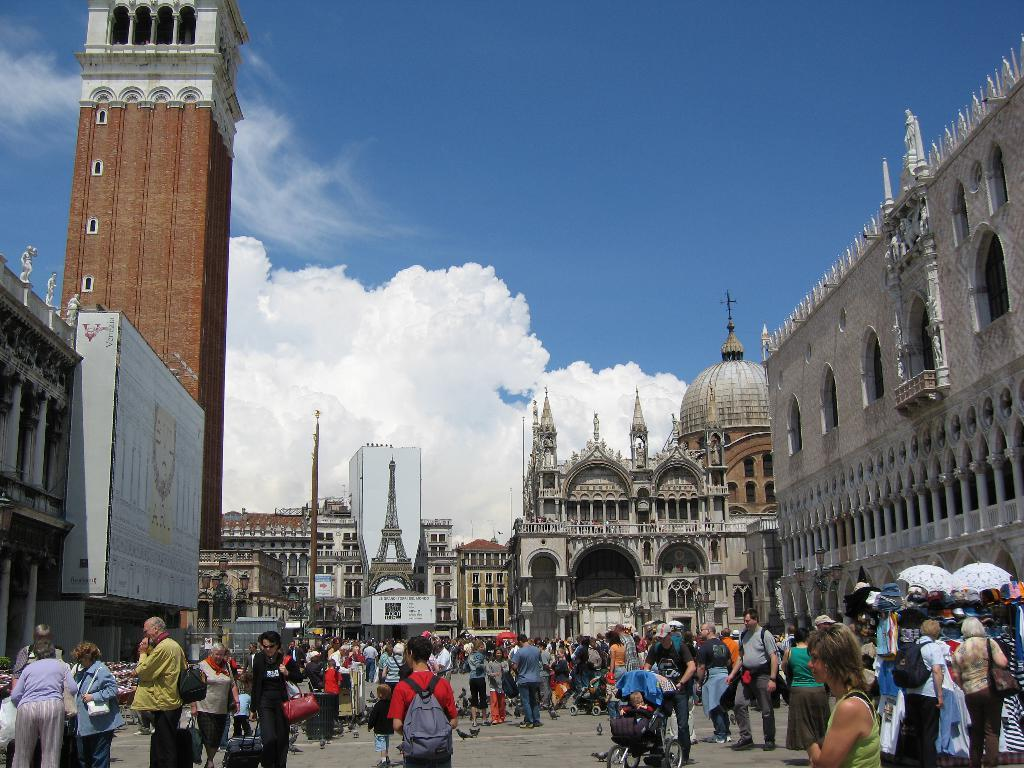What are the people in the image doing? The people in the image are walking. What structures can be seen in the image? There are buildings in the image. What color is the sky in the image? The sky is blue in the image. What books are the people using to guide them in the image? There are no books present in the image, and the people are not using any guides. How are the people blowing in the image? There is no blowing activity depicted in the image. 